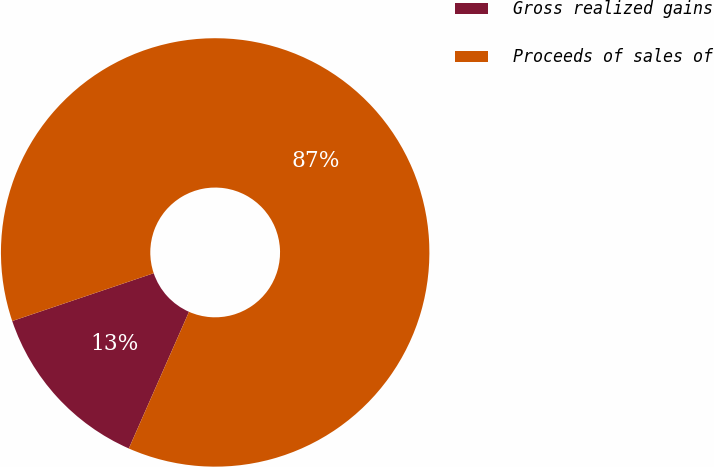Convert chart to OTSL. <chart><loc_0><loc_0><loc_500><loc_500><pie_chart><fcel>Gross realized gains<fcel>Proceeds of sales of<nl><fcel>13.21%<fcel>86.79%<nl></chart> 